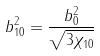Convert formula to latex. <formula><loc_0><loc_0><loc_500><loc_500>b _ { 1 0 } ^ { 2 } = \frac { b _ { 0 } ^ { 2 } } { \sqrt { 3 \chi _ { 1 0 } } }</formula> 